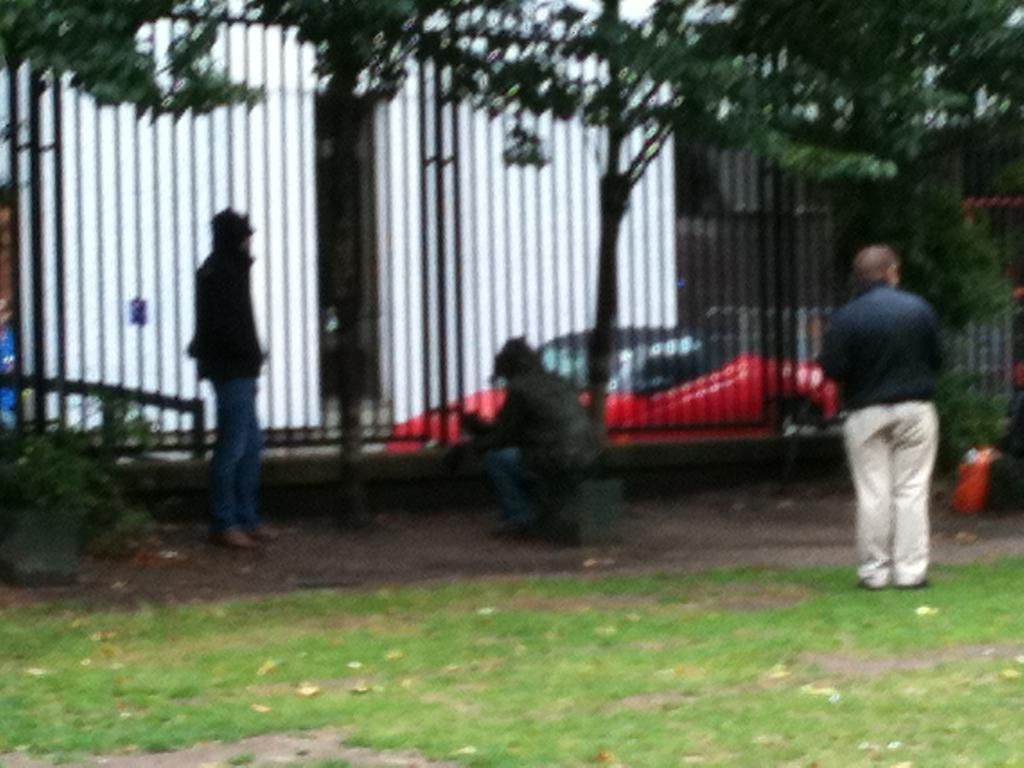In one or two sentences, can you explain what this image depicts? In the center of the image a man is sitting on his knees. On the left and right side of the image two persons are standing. In the background of the image we can see grills, trees, car, plants and some objects. At the bottom of the image there is a ground. 